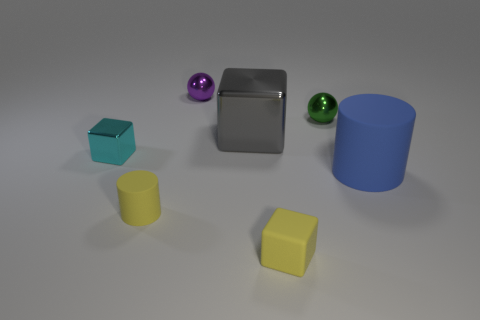Does the big blue object have the same material as the tiny cyan block?
Offer a very short reply. No. There is a yellow object that is to the right of the large metallic object; what is its size?
Keep it short and to the point. Small. What number of things have the same color as the tiny cylinder?
Ensure brevity in your answer.  1. There is a yellow object to the left of the purple ball; is there a cyan block that is in front of it?
Make the answer very short. No. Do the matte cylinder left of the large gray thing and the cube that is on the right side of the big gray thing have the same color?
Offer a terse response. Yes. There is a rubber cylinder that is the same size as the purple metal sphere; what color is it?
Your answer should be compact. Yellow. Are there an equal number of cyan things in front of the cyan metallic thing and tiny green objects in front of the large blue matte cylinder?
Your response must be concise. Yes. There is a cylinder on the left side of the cylinder that is behind the tiny cylinder; what is it made of?
Make the answer very short. Rubber. What number of objects are either tiny metal spheres or large gray metal cubes?
Your answer should be very brief. 3. The rubber block that is the same color as the tiny matte cylinder is what size?
Your answer should be compact. Small. 